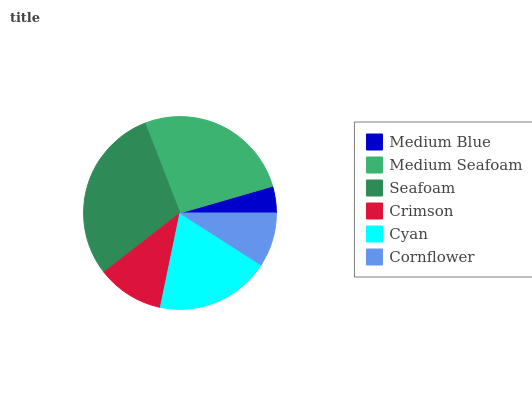Is Medium Blue the minimum?
Answer yes or no. Yes. Is Seafoam the maximum?
Answer yes or no. Yes. Is Medium Seafoam the minimum?
Answer yes or no. No. Is Medium Seafoam the maximum?
Answer yes or no. No. Is Medium Seafoam greater than Medium Blue?
Answer yes or no. Yes. Is Medium Blue less than Medium Seafoam?
Answer yes or no. Yes. Is Medium Blue greater than Medium Seafoam?
Answer yes or no. No. Is Medium Seafoam less than Medium Blue?
Answer yes or no. No. Is Cyan the high median?
Answer yes or no. Yes. Is Crimson the low median?
Answer yes or no. Yes. Is Cornflower the high median?
Answer yes or no. No. Is Cyan the low median?
Answer yes or no. No. 